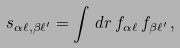Convert formula to latex. <formula><loc_0><loc_0><loc_500><loc_500>s _ { \alpha \ell , \beta \ell ^ { \prime } } = \int \, d { r } \, f _ { \alpha \ell } \, f _ { \beta \ell ^ { \prime } } \, ,</formula> 